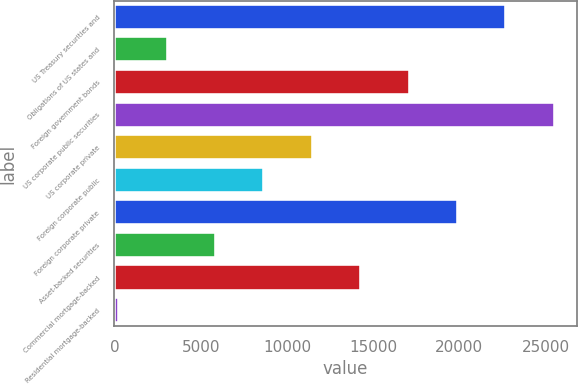<chart> <loc_0><loc_0><loc_500><loc_500><bar_chart><fcel>US Treasury securities and<fcel>Obligations of US states and<fcel>Foreign government bonds<fcel>US corporate public securities<fcel>US corporate private<fcel>Foreign corporate public<fcel>Foreign corporate private<fcel>Asset-backed securities<fcel>Commercial mortgage-backed<fcel>Residential mortgage-backed<nl><fcel>22726<fcel>3091<fcel>17116<fcel>25531<fcel>11506<fcel>8701<fcel>19921<fcel>5896<fcel>14311<fcel>286<nl></chart> 